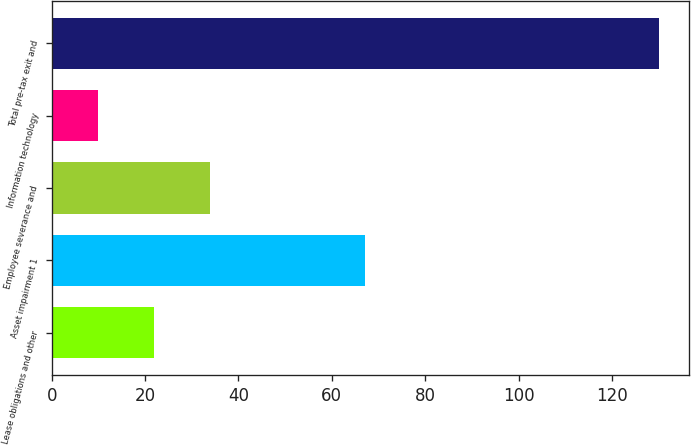Convert chart. <chart><loc_0><loc_0><loc_500><loc_500><bar_chart><fcel>Lease obligations and other<fcel>Asset impairment 1<fcel>Employee severance and<fcel>Information technology<fcel>Total pre-tax exit and<nl><fcel>22<fcel>67<fcel>34<fcel>10<fcel>130<nl></chart> 